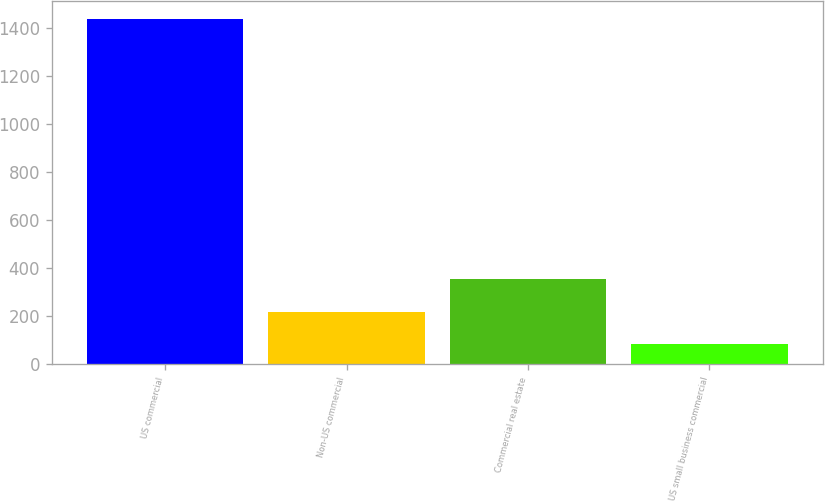Convert chart to OTSL. <chart><loc_0><loc_0><loc_500><loc_500><bar_chart><fcel>US commercial<fcel>Non-US commercial<fcel>Commercial real estate<fcel>US small business commercial<nl><fcel>1437<fcel>218.4<fcel>353.8<fcel>83<nl></chart> 